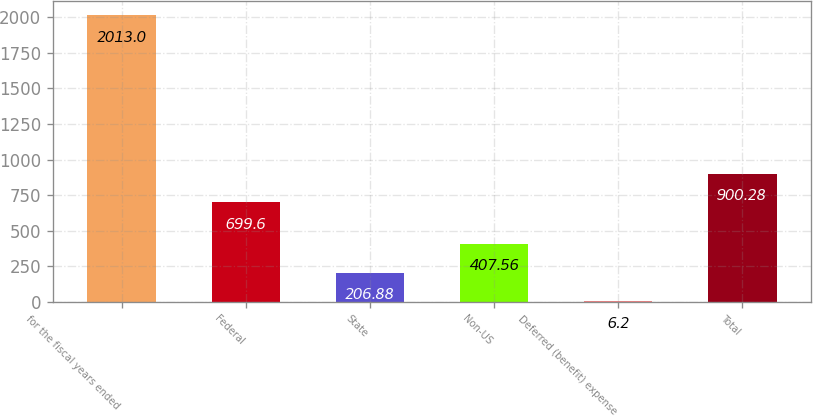Convert chart. <chart><loc_0><loc_0><loc_500><loc_500><bar_chart><fcel>for the fiscal years ended<fcel>Federal<fcel>State<fcel>Non-US<fcel>Deferred (benefit) expense<fcel>Total<nl><fcel>2013<fcel>699.6<fcel>206.88<fcel>407.56<fcel>6.2<fcel>900.28<nl></chart> 